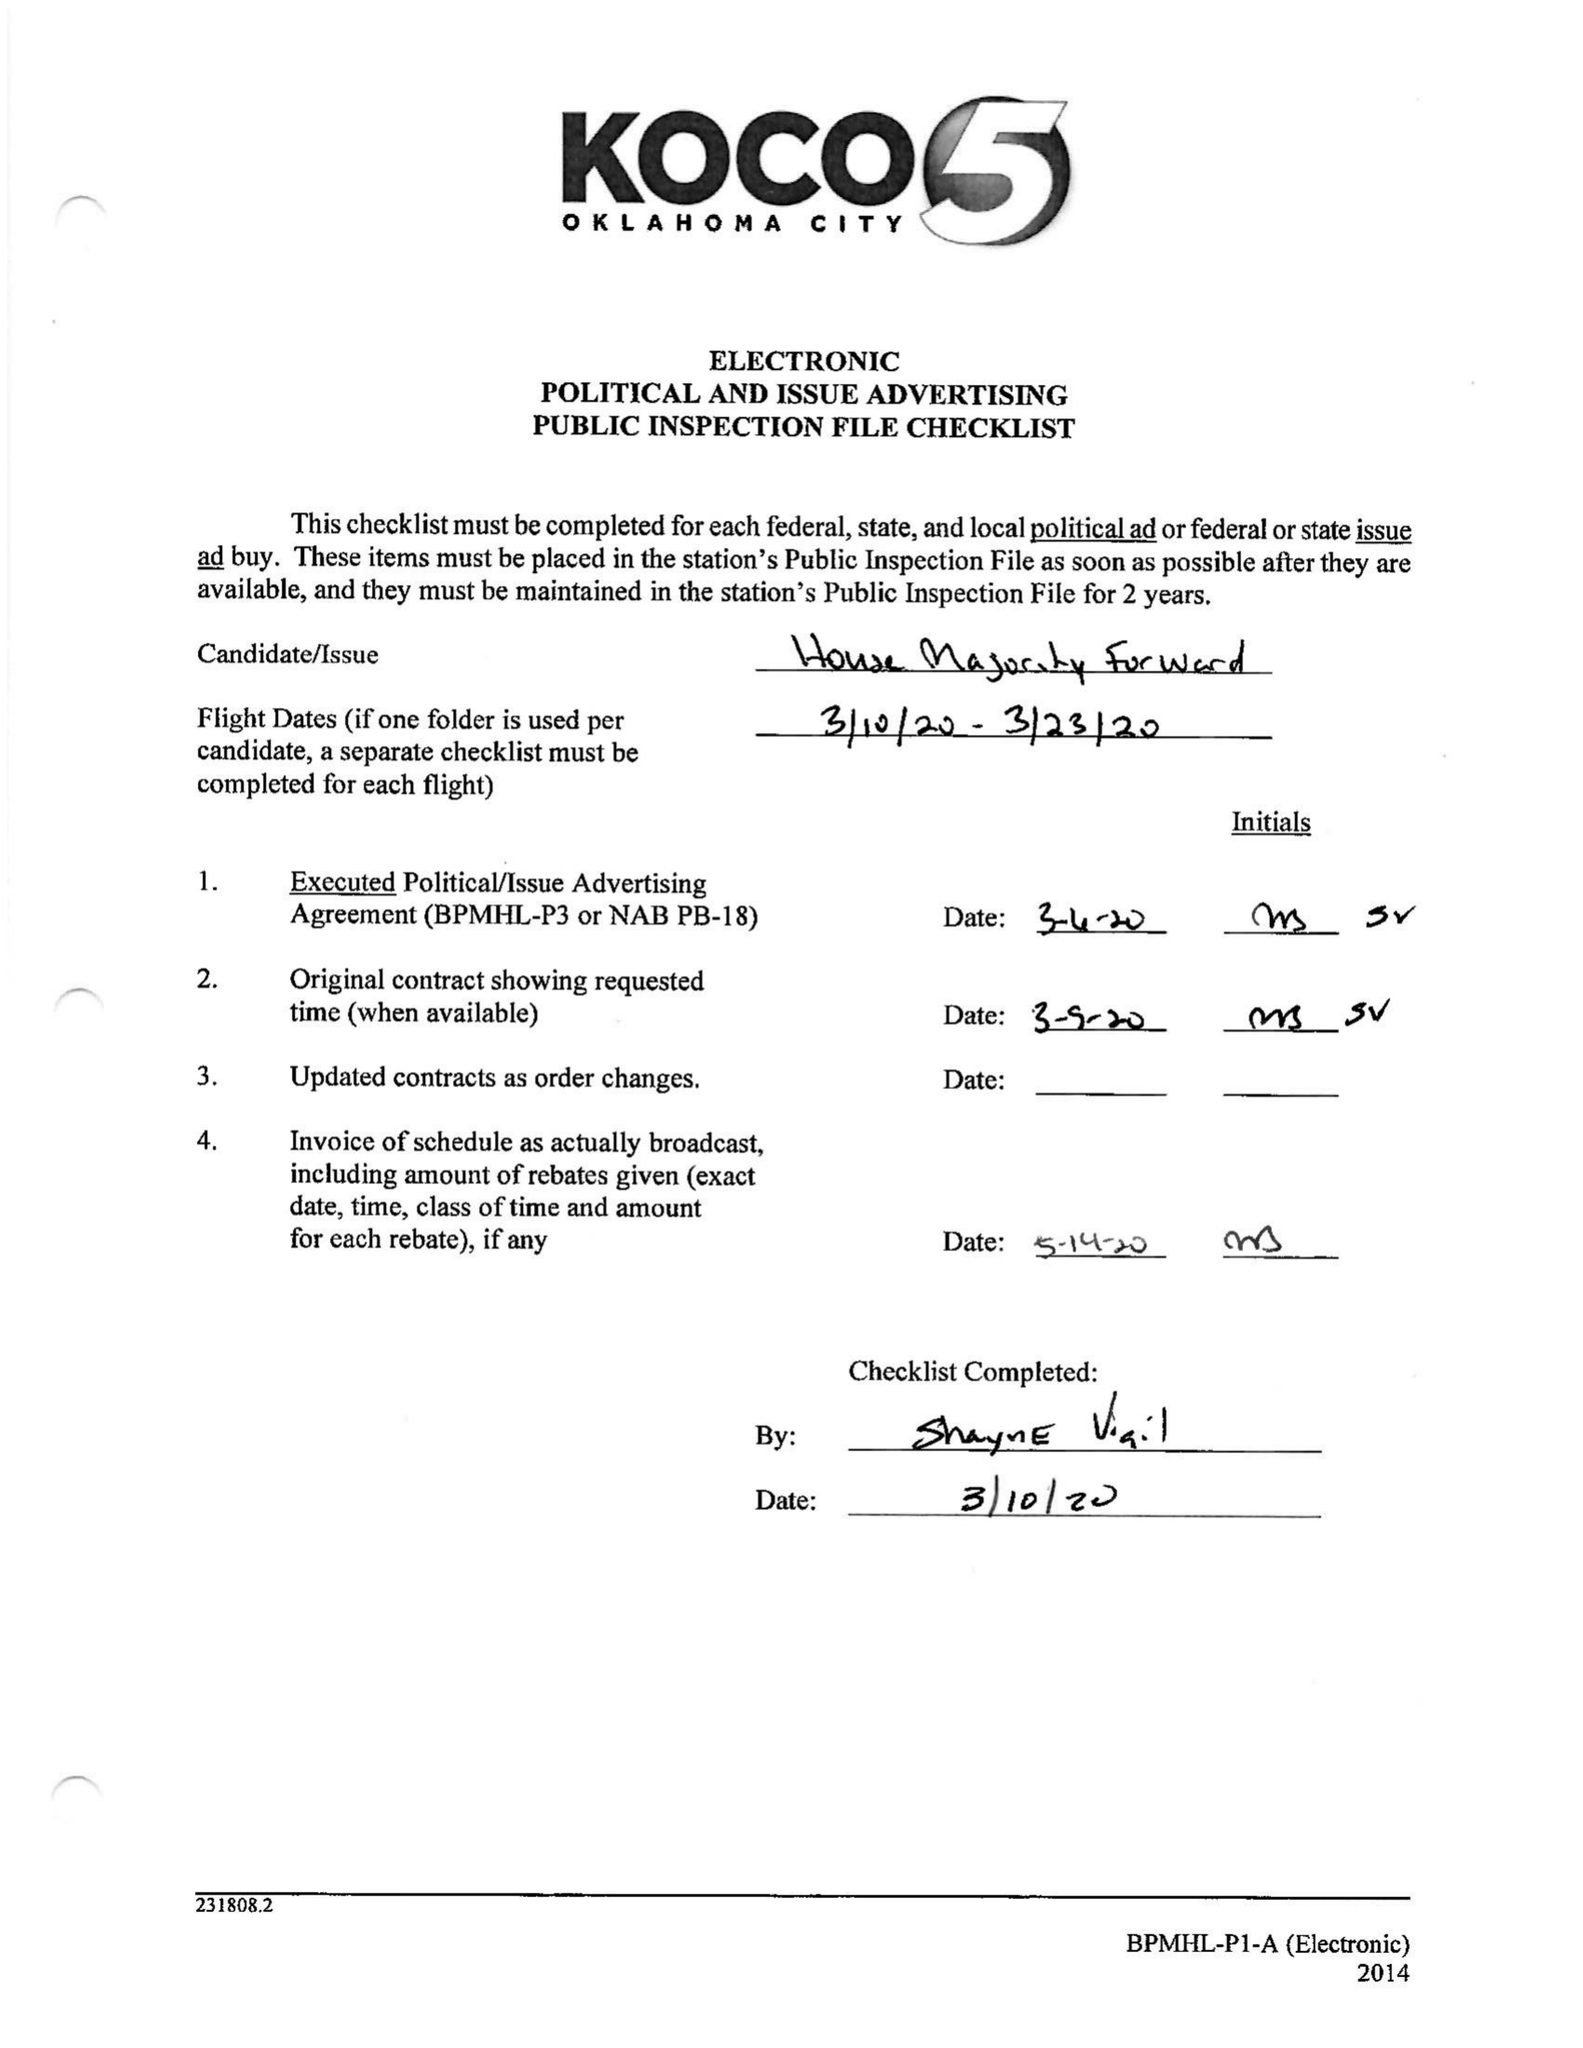What is the value for the flight_to?
Answer the question using a single word or phrase. 03/23/20 